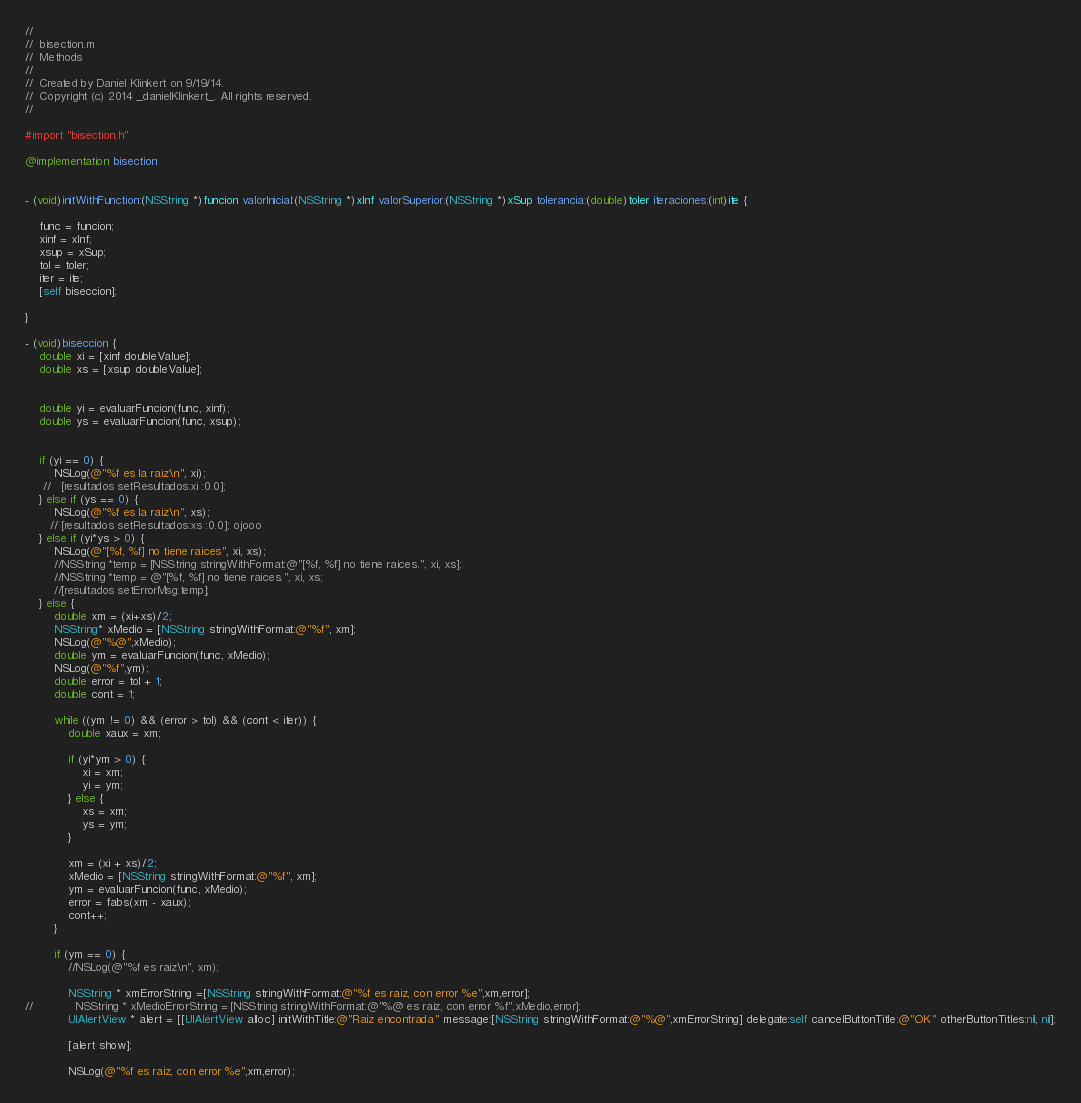Convert code to text. <code><loc_0><loc_0><loc_500><loc_500><_ObjectiveC_>//
//  bisection.m
//  Methods
//
//  Created by Daniel Klinkert on 9/19/14.
//  Copyright (c) 2014 _danielKlinkert_. All rights reserved.
//

#import "bisection.h"

@implementation bisection


- (void)initWithFunction:(NSString *)funcion valorInicial:(NSString *)xInf valorSuperior:(NSString *)xSup tolerancia:(double)toler iteraciones:(int)ite {
    
    func = funcion;
    xinf = xInf;
    xsup = xSup;
    tol = toler;
    iter = ite;
    [self biseccion];
    
}

- (void)biseccion {
    double xi = [xinf doubleValue];
    double xs = [xsup doubleValue];
    
    
    double yi = evaluarFuncion(func, xinf);
    double ys = evaluarFuncion(func, xsup);
    
    
    if (yi == 0) {
        NSLog(@"%f es la raiz\n", xi);
     //   [resultados setResultados:xi :0.0];
    } else if (ys == 0) {
        NSLog(@"%f es la raiz\n", xs);
       // [resultados setResultados:xs :0.0]; ojooo
    } else if (yi*ys > 0) {
        NSLog(@"[%f, %f] no tiene raices", xi, xs);
        //NSString *temp = [NSString stringWithFormat:@"[%f, %f] no tiene raices.", xi, xs];
        //NSString *temp = @"[%f, %f] no tiene raices.", xi, xs;
        //[resultados setErrorMsg:temp];
    } else {
        double xm = (xi+xs)/2;
        NSString* xMedio = [NSString stringWithFormat:@"%f", xm];
        NSLog(@"%@",xMedio);
        double ym = evaluarFuncion(func, xMedio);
        NSLog(@"%f",ym);
        double error = tol + 1;
        double cont = 1;
        
        while ((ym != 0) && (error > tol) && (cont < iter)) {
            double xaux = xm;
            
            if (yi*ym > 0) {
                xi = xm;
                yi = ym;
            } else {
                xs = xm;
                ys = ym;
            }
            
            xm = (xi + xs)/2;
            xMedio = [NSString stringWithFormat:@"%f", xm];
            ym = evaluarFuncion(func, xMedio);
            error = fabs(xm - xaux);
            cont++;
        }
        
        if (ym == 0) {
            //NSLog(@"%f es raiz\n", xm);
            
            NSString * xmErrorString =[NSString stringWithFormat:@"%f es raiz, con error %e",xm,error];
//            NSString * xMedioErrorString = [NSString stringWithFormat:@"%@ es raiz, con error %f",xMedio,error];
            UIAlertView * alert = [[UIAlertView alloc] initWithTitle:@"Raiz encontrada" message:[NSString stringWithFormat:@"%@",xmErrorString] delegate:self cancelButtonTitle:@"OK" otherButtonTitles:nil, nil];
            
            [alert show];

            NSLog(@"%f es raiz, con error %e",xm,error);</code> 